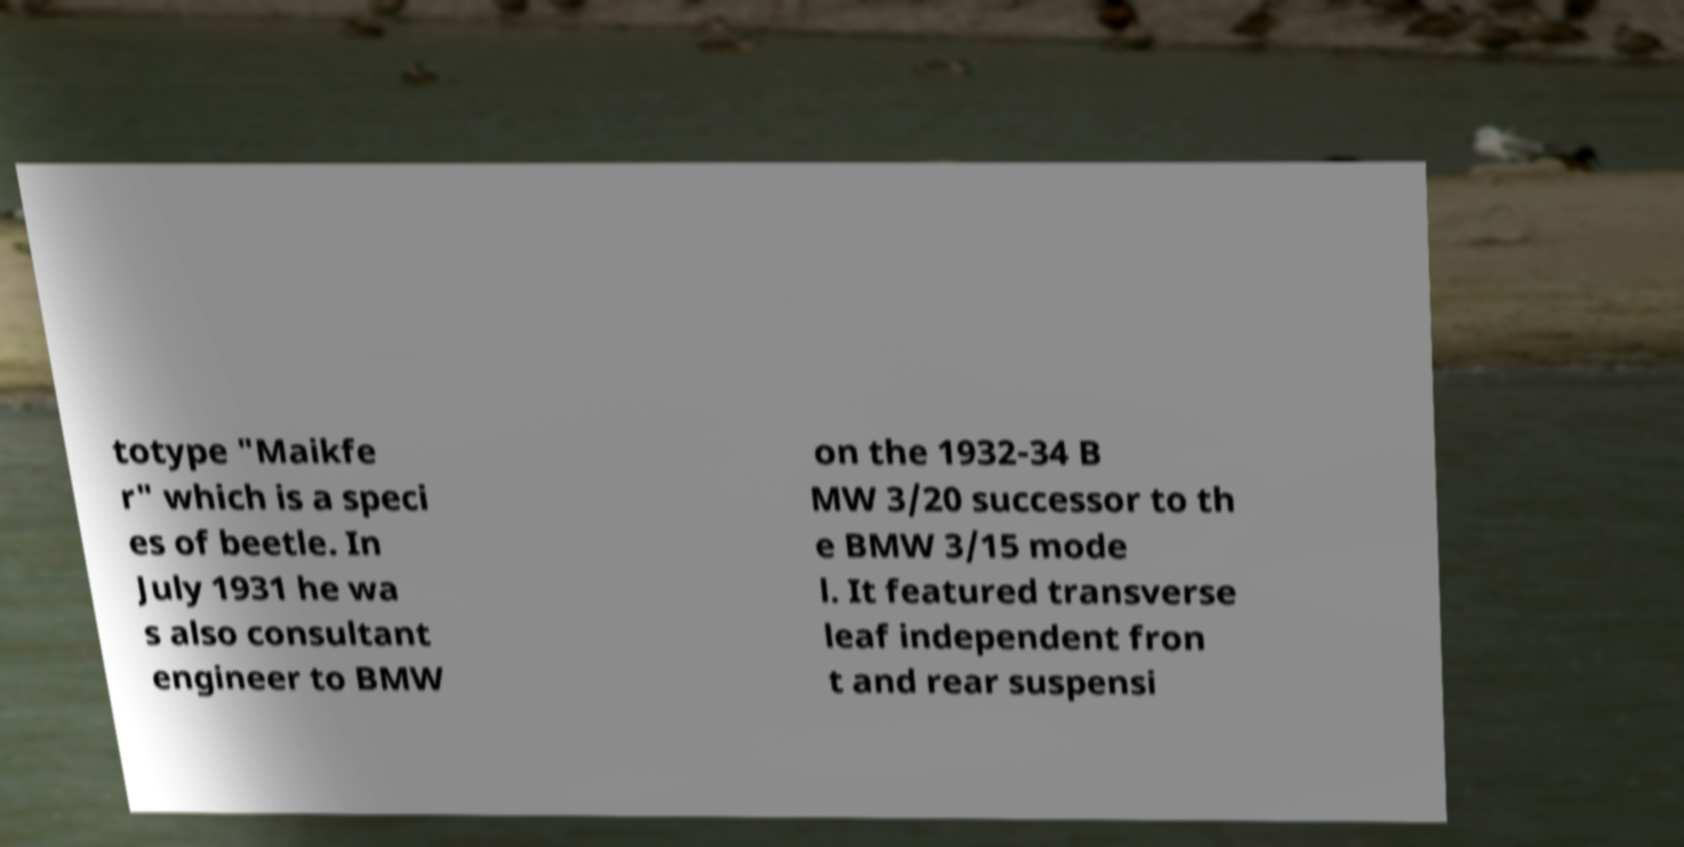Could you assist in decoding the text presented in this image and type it out clearly? totype "Maikfe r" which is a speci es of beetle. In July 1931 he wa s also consultant engineer to BMW on the 1932-34 B MW 3/20 successor to th e BMW 3/15 mode l. It featured transverse leaf independent fron t and rear suspensi 